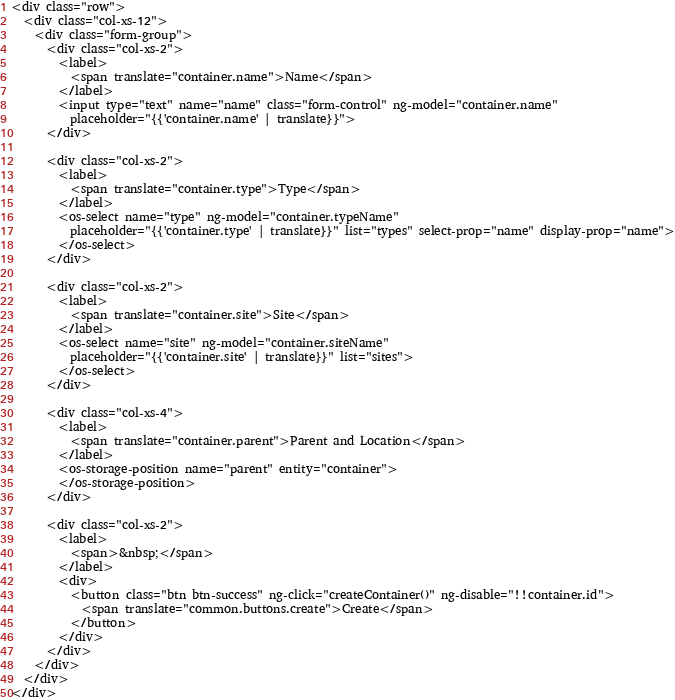<code> <loc_0><loc_0><loc_500><loc_500><_HTML_><div class="row">
  <div class="col-xs-12">
    <div class="form-group">
      <div class="col-xs-2">
        <label>
          <span translate="container.name">Name</span>
        </label>
        <input type="text" name="name" class="form-control" ng-model="container.name"
          placeholder="{{'container.name' | translate}}">
      </div>

      <div class="col-xs-2">
        <label>
          <span translate="container.type">Type</span>
        </label>
        <os-select name="type" ng-model="container.typeName"
          placeholder="{{'container.type' | translate}}" list="types" select-prop="name" display-prop="name">
        </os-select>
      </div>

      <div class="col-xs-2">
        <label>
          <span translate="container.site">Site</span>
        </label>
        <os-select name="site" ng-model="container.siteName" 
          placeholder="{{'container.site' | translate}}" list="sites">
        </os-select>
      </div>

      <div class="col-xs-4">
        <label>
          <span translate="container.parent">Parent and Location</span>
        </label>
        <os-storage-position name="parent" entity="container">
        </os-storage-position>
      </div>

      <div class="col-xs-2">
        <label>
          <span>&nbsp;</span>
        </label>
        <div>
          <button class="btn btn-success" ng-click="createContainer()" ng-disable="!!container.id">
            <span translate="common.buttons.create">Create</span>
          </button>
        </div>
      </div>
    </div>
  </div>
</div>
</code> 